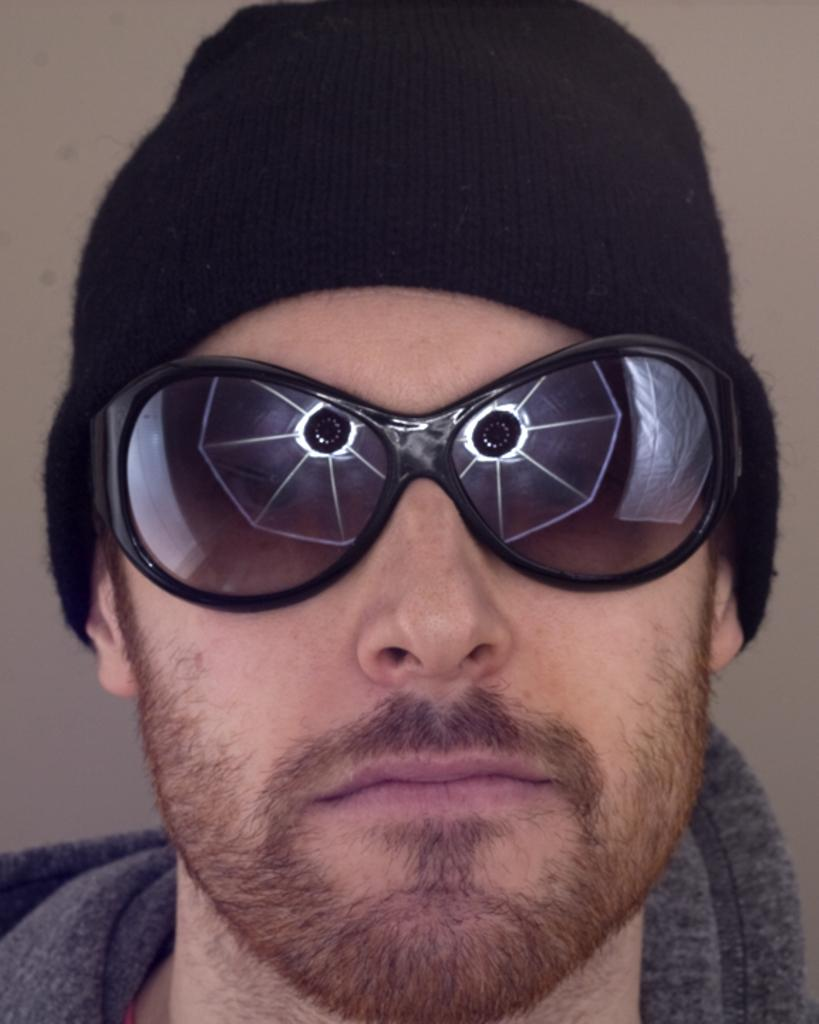Who or what is present in the image? There is a person in the image. What is the person wearing in the image? The person is wearing sunglasses. What can be seen in the background of the image? There is a wall in the background of the image. What type of arithmetic problem is the person solving in the image? There is no arithmetic problem visible in the image. What kind of cracker is the person holding in the image? There is no cracker present in the image. 